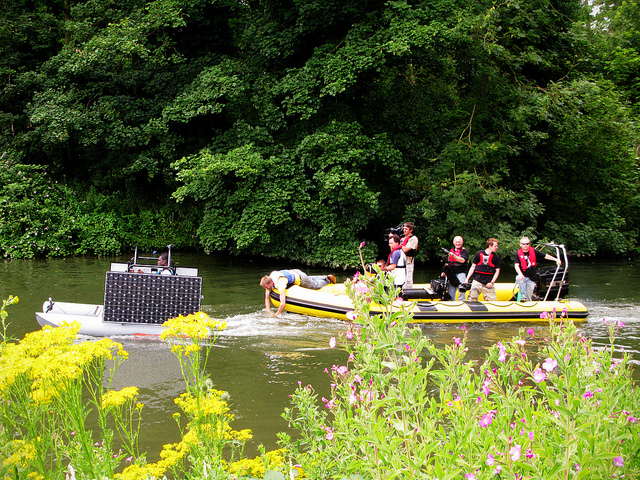Can you tell me more about the surroundings of this river? The river is bordered by lush, vibrant greenery, suggesting a healthy ecosystem. It's a scenic spot that likely attracts both nature enthusiasts and those looking for leisure activities. The flowering plants on the banks add to the picturesque quality of the location. 